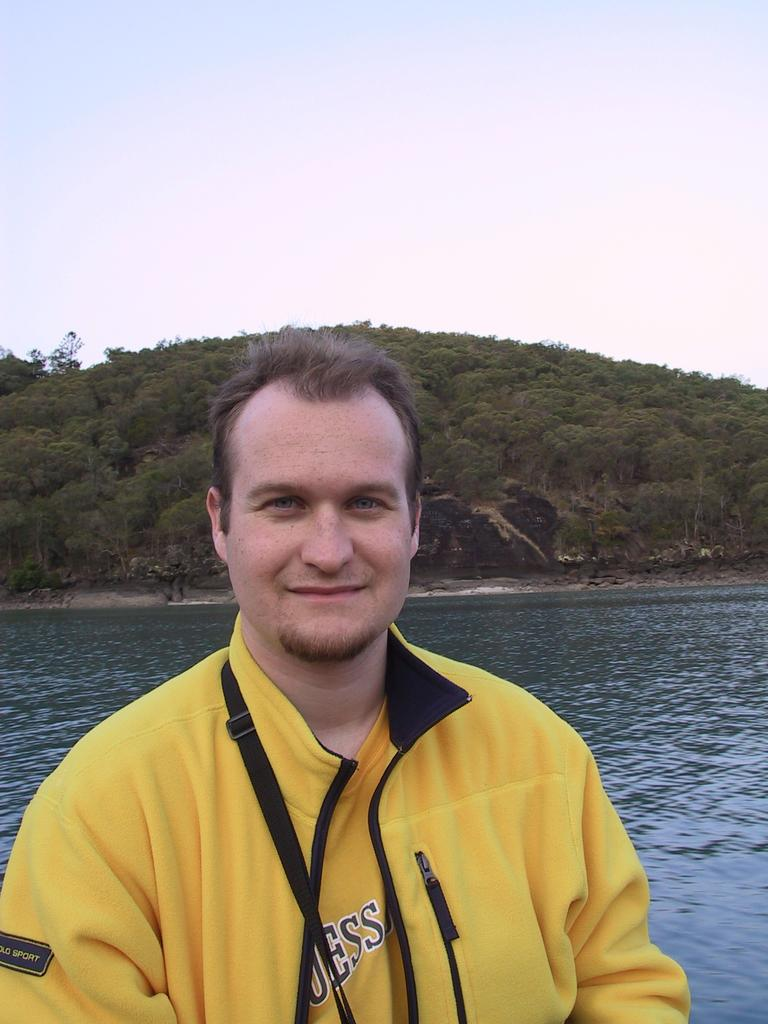<image>
Write a terse but informative summary of the picture. A man is on a lake wearing a yellow Guess shirt. 